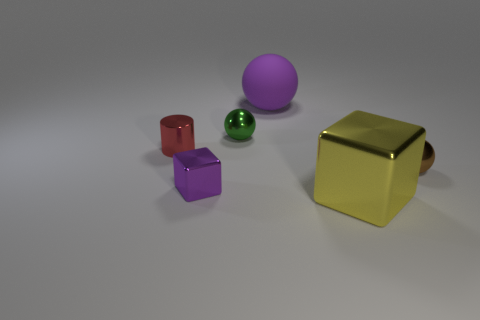What number of other objects are there of the same material as the large purple sphere?
Offer a terse response. 0. Is there anything else that is the same shape as the tiny red metal thing?
Offer a terse response. No. Is the material of the small purple thing the same as the purple thing behind the brown metal sphere?
Your response must be concise. No. Is there a large thing that is right of the large thing that is on the right side of the big thing that is behind the large shiny block?
Your answer should be compact. No. The big object that is made of the same material as the cylinder is what color?
Provide a succinct answer. Yellow. There is a object that is in front of the brown shiny sphere and right of the big purple rubber sphere; how big is it?
Ensure brevity in your answer.  Large. Is the number of tiny brown things to the left of the yellow metallic block less than the number of red objects behind the tiny cylinder?
Your answer should be very brief. No. Is the material of the tiny ball in front of the tiny red metallic cylinder the same as the purple object behind the small red object?
Your response must be concise. No. What is the material of the cube that is the same color as the big matte thing?
Offer a very short reply. Metal. There is a small thing that is both to the left of the green metallic sphere and in front of the small red object; what shape is it?
Offer a terse response. Cube. 